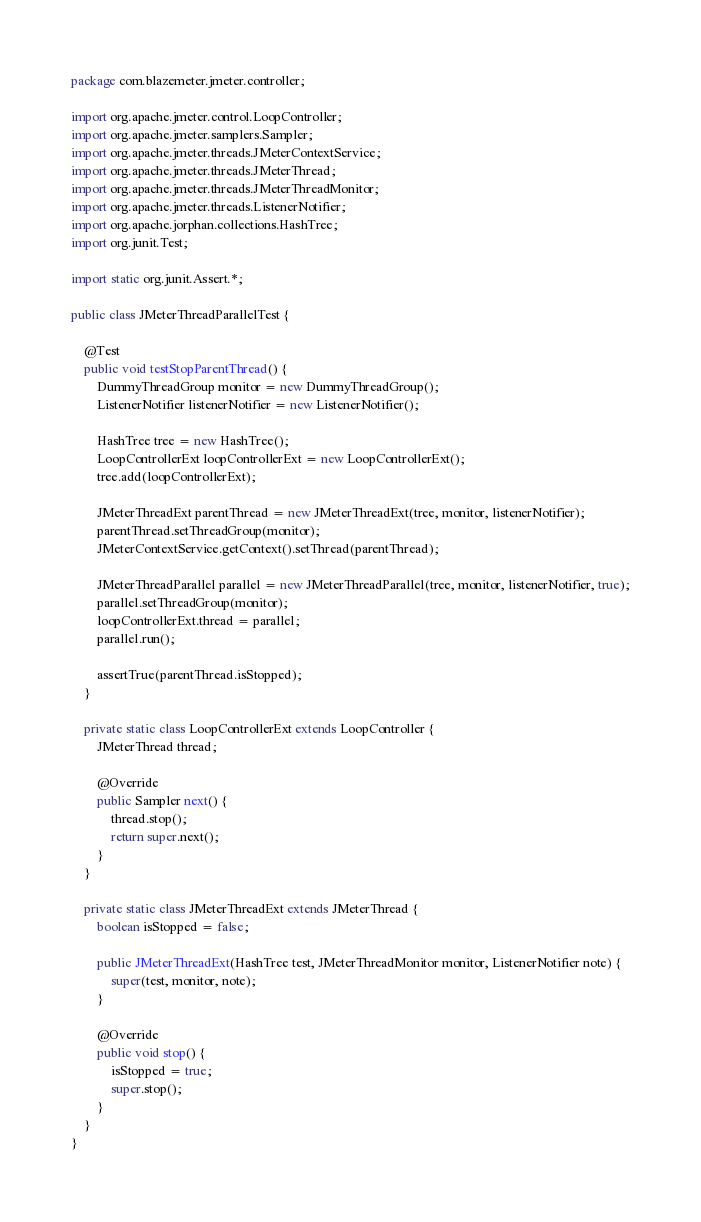Convert code to text. <code><loc_0><loc_0><loc_500><loc_500><_Java_>package com.blazemeter.jmeter.controller;

import org.apache.jmeter.control.LoopController;
import org.apache.jmeter.samplers.Sampler;
import org.apache.jmeter.threads.JMeterContextService;
import org.apache.jmeter.threads.JMeterThread;
import org.apache.jmeter.threads.JMeterThreadMonitor;
import org.apache.jmeter.threads.ListenerNotifier;
import org.apache.jorphan.collections.HashTree;
import org.junit.Test;

import static org.junit.Assert.*;

public class JMeterThreadParallelTest {

    @Test
    public void testStopParentThread() {
        DummyThreadGroup monitor = new DummyThreadGroup();
        ListenerNotifier listenerNotifier = new ListenerNotifier();

        HashTree tree = new HashTree();
        LoopControllerExt loopControllerExt = new LoopControllerExt();
        tree.add(loopControllerExt);

        JMeterThreadExt parentThread = new JMeterThreadExt(tree, monitor, listenerNotifier);
        parentThread.setThreadGroup(monitor);
        JMeterContextService.getContext().setThread(parentThread);

        JMeterThreadParallel parallel = new JMeterThreadParallel(tree, monitor, listenerNotifier, true);
        parallel.setThreadGroup(monitor);
        loopControllerExt.thread = parallel;
        parallel.run();

        assertTrue(parentThread.isStopped);
    }

    private static class LoopControllerExt extends LoopController {
        JMeterThread thread;

        @Override
        public Sampler next() {
            thread.stop();
            return super.next();
        }
    }

    private static class JMeterThreadExt extends JMeterThread {
        boolean isStopped = false;

        public JMeterThreadExt(HashTree test, JMeterThreadMonitor monitor, ListenerNotifier note) {
            super(test, monitor, note);
        }

        @Override
        public void stop() {
            isStopped = true;
            super.stop();
        }
    }
}</code> 